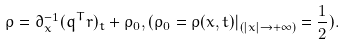<formula> <loc_0><loc_0><loc_500><loc_500>\rho = \partial ^ { - 1 } _ { x } ( q ^ { T } r ) _ { t } + \rho _ { 0 } , ( \rho _ { 0 } = \rho ( x , t ) | _ { ( | x | \rightarrow + \infty ) } = \frac { 1 } { 2 } ) .</formula> 